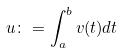<formula> <loc_0><loc_0><loc_500><loc_500>u \colon = \int _ { a } ^ { b } v ( t ) d t</formula> 